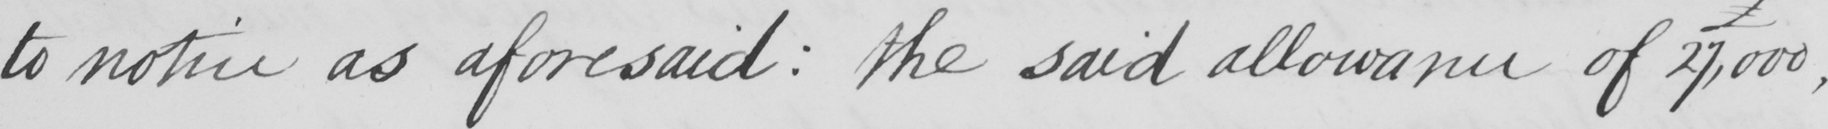Please provide the text content of this handwritten line. to notice as aforesaid  :  the said allowance of 27,000 , 